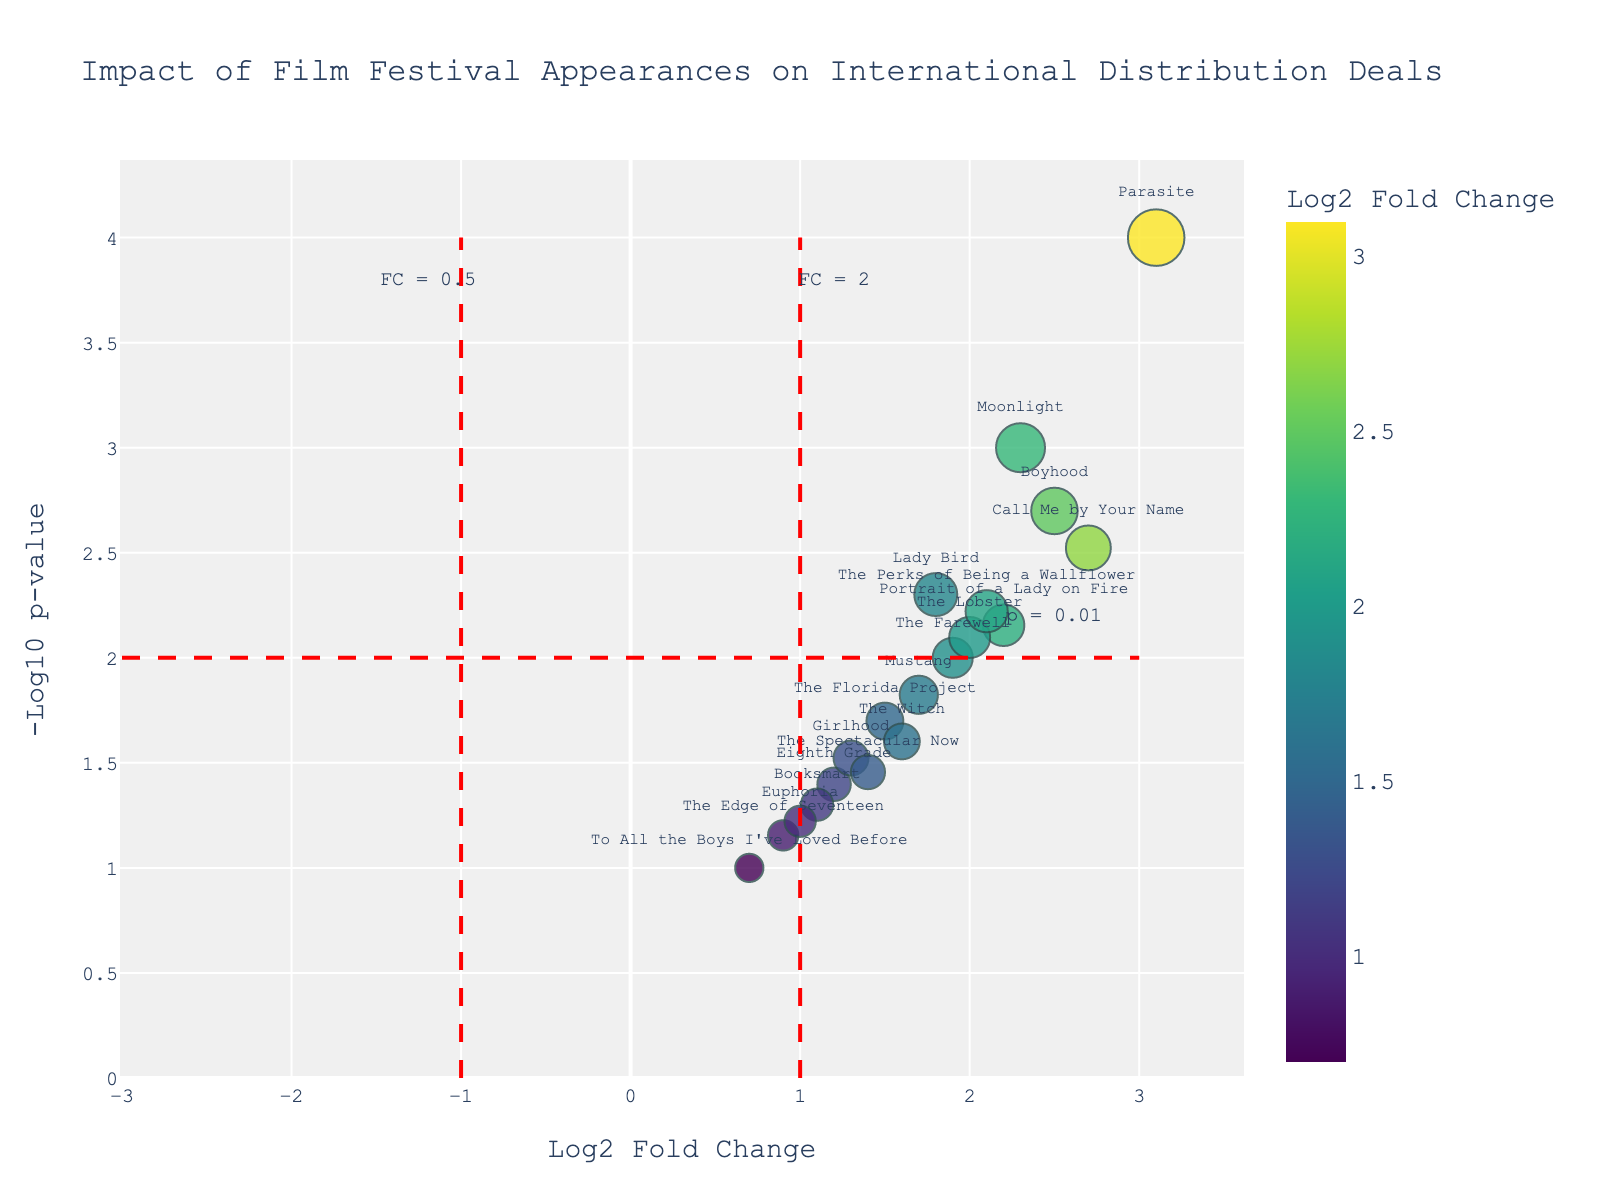what is the title of the plot? The title is usually located at the top center of the plot. The title here reads "Impact of Film Festival Appearances on International Distribution Deals".
Answer: Impact of Film Festival Appearances on International Distribution Deals Which film has the highest log2 fold change? By examining the x-axis, which represents the log2 fold change, we look for the data point with the highest value. The highest log2 fold change value is 3.1, corresponding to "Parasite".
Answer: Parasite How many films have a p-value less than 0.01? To find the number of films with a p-value less than 0.01, we count the data points that fall above the -log10(p) = 2 line on the y-axis. There are 8 such films.
Answer: 8 Which film has the smallest log2 fold change and what is its p-value? By looking at the point closest to the leftmost side of the x-axis, we find that "To All the Boys I've Loved Before" has the smallest log2 fold change of 0.7. The associated p-value can be read from the hover data or by reference to the table provided.
Answer: To All the Boys I've Loved Before, 0.1 What is the log2 fold change value for "Call Me by Your Name"? By finding the data point "Call Me by Your Name" on the plot, we note its x-axis value, which corresponds to the log2 fold change. The value is 2.7.
Answer: 2.7 How many films have a log2 fold change greater than 2? To determine this, we count the number of data points that are located to the right of the x-axis line at log2 fold change = 2. There are 6 such films.
Answer: 6 Which film has a p-value of 0.025 and what is its log2 fold change? To find the film with a p-value of 0.025, we locate the corresponding point on the y-axis by the -log10(p) value ∼ 1.6. The film is "The Witch", with a log2 fold change around 1.6.
Answer: The Witch, 1.6 Compare "Boyhood" and "Booksmart" in terms of p-value and log2 fold change. Which one has a higher impact based on festival appearances? To compare, we locate both films on the plot. "Boyhood" has a log2 fold change of 2.5 and a p-value of 0.002. "Booksmart" has a log2 fold change of 1.1 and a p-value of 0.05. A higher log2 fold change and lower p-value indicate a stronger impact, so "Boyhood" has the higher impact.
Answer: Boyhood What does the red dashed line at -log10(p) = 2 represent? The horizontal red dashed line at -log10(p) = 2 indicates a p-value significance threshold of 0.01 (since -log10(0.01) = 2). Data points above this line have p-values less than 0.01, indicating statistically significant results.
Answer: p-value threshold = 0.01 